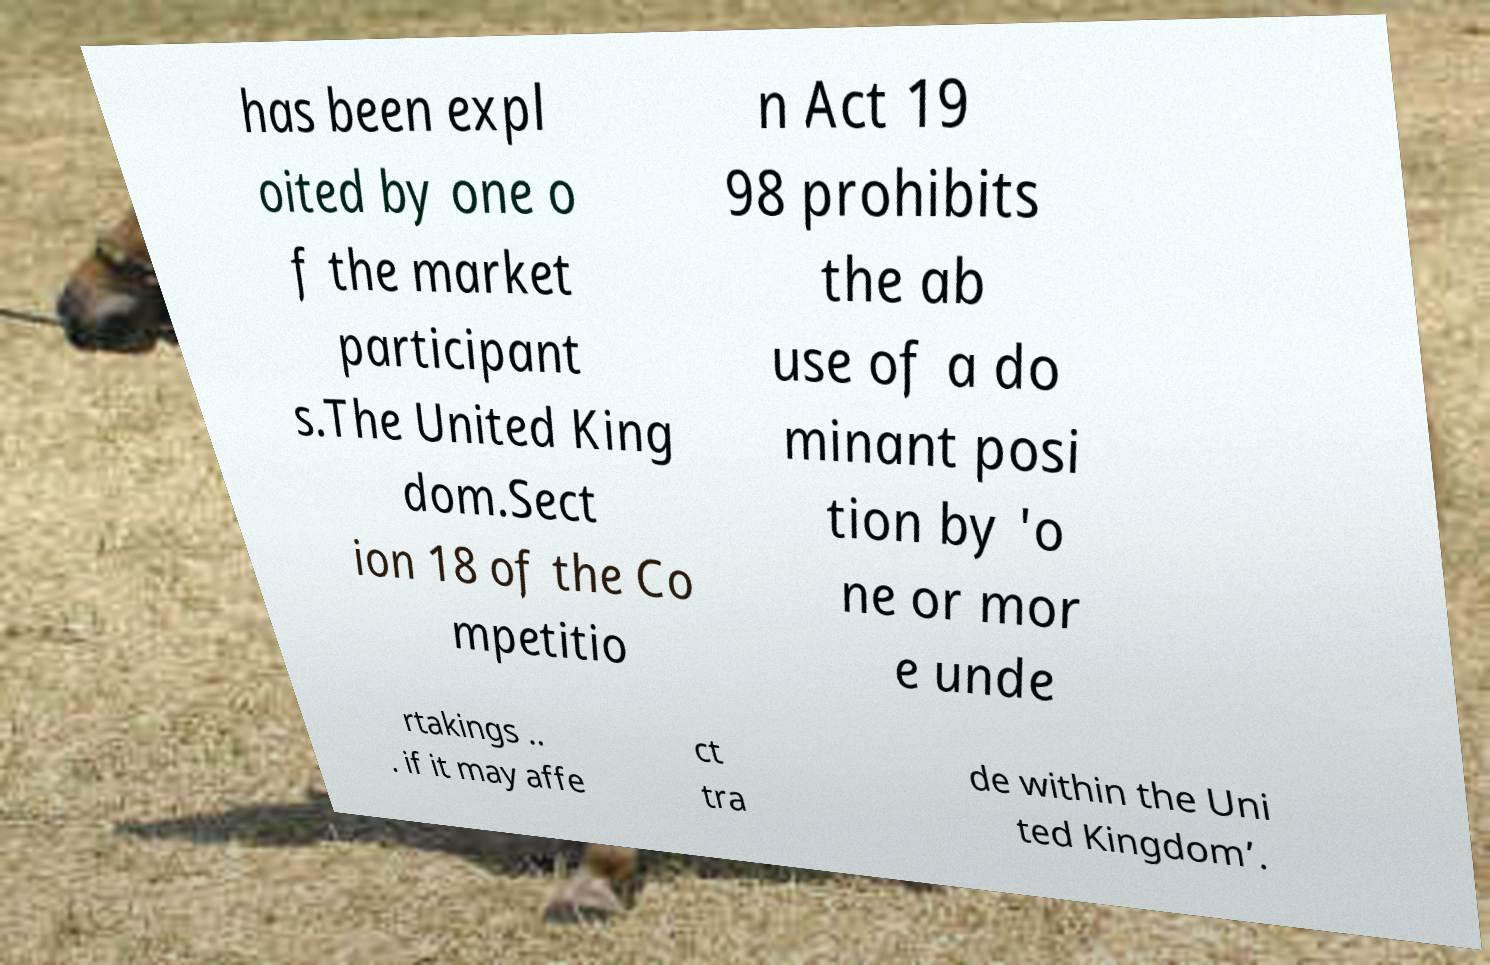Could you assist in decoding the text presented in this image and type it out clearly? has been expl oited by one o f the market participant s.The United King dom.Sect ion 18 of the Co mpetitio n Act 19 98 prohibits the ab use of a do minant posi tion by 'o ne or mor e unde rtakings .. . if it may affe ct tra de within the Uni ted Kingdom’. 